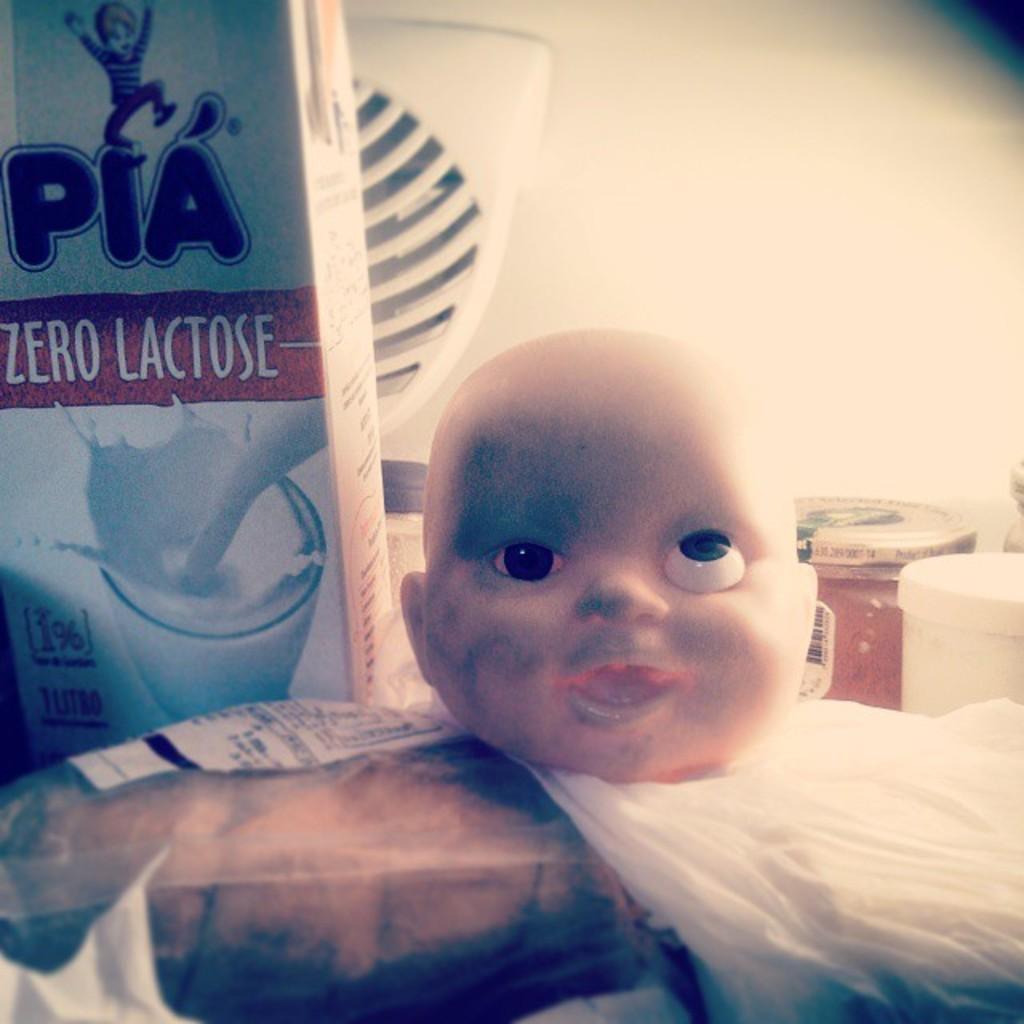Describe this image in one or two sentences. We can see doll face,covers and box,behind this doll face we can see jars. 